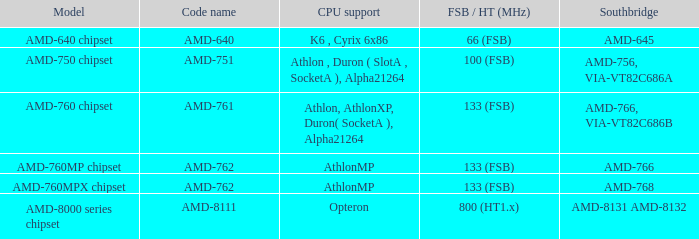What do the terms amd-766 and via-vt82c686b represent as code names for the southbridge? AMD-761. 